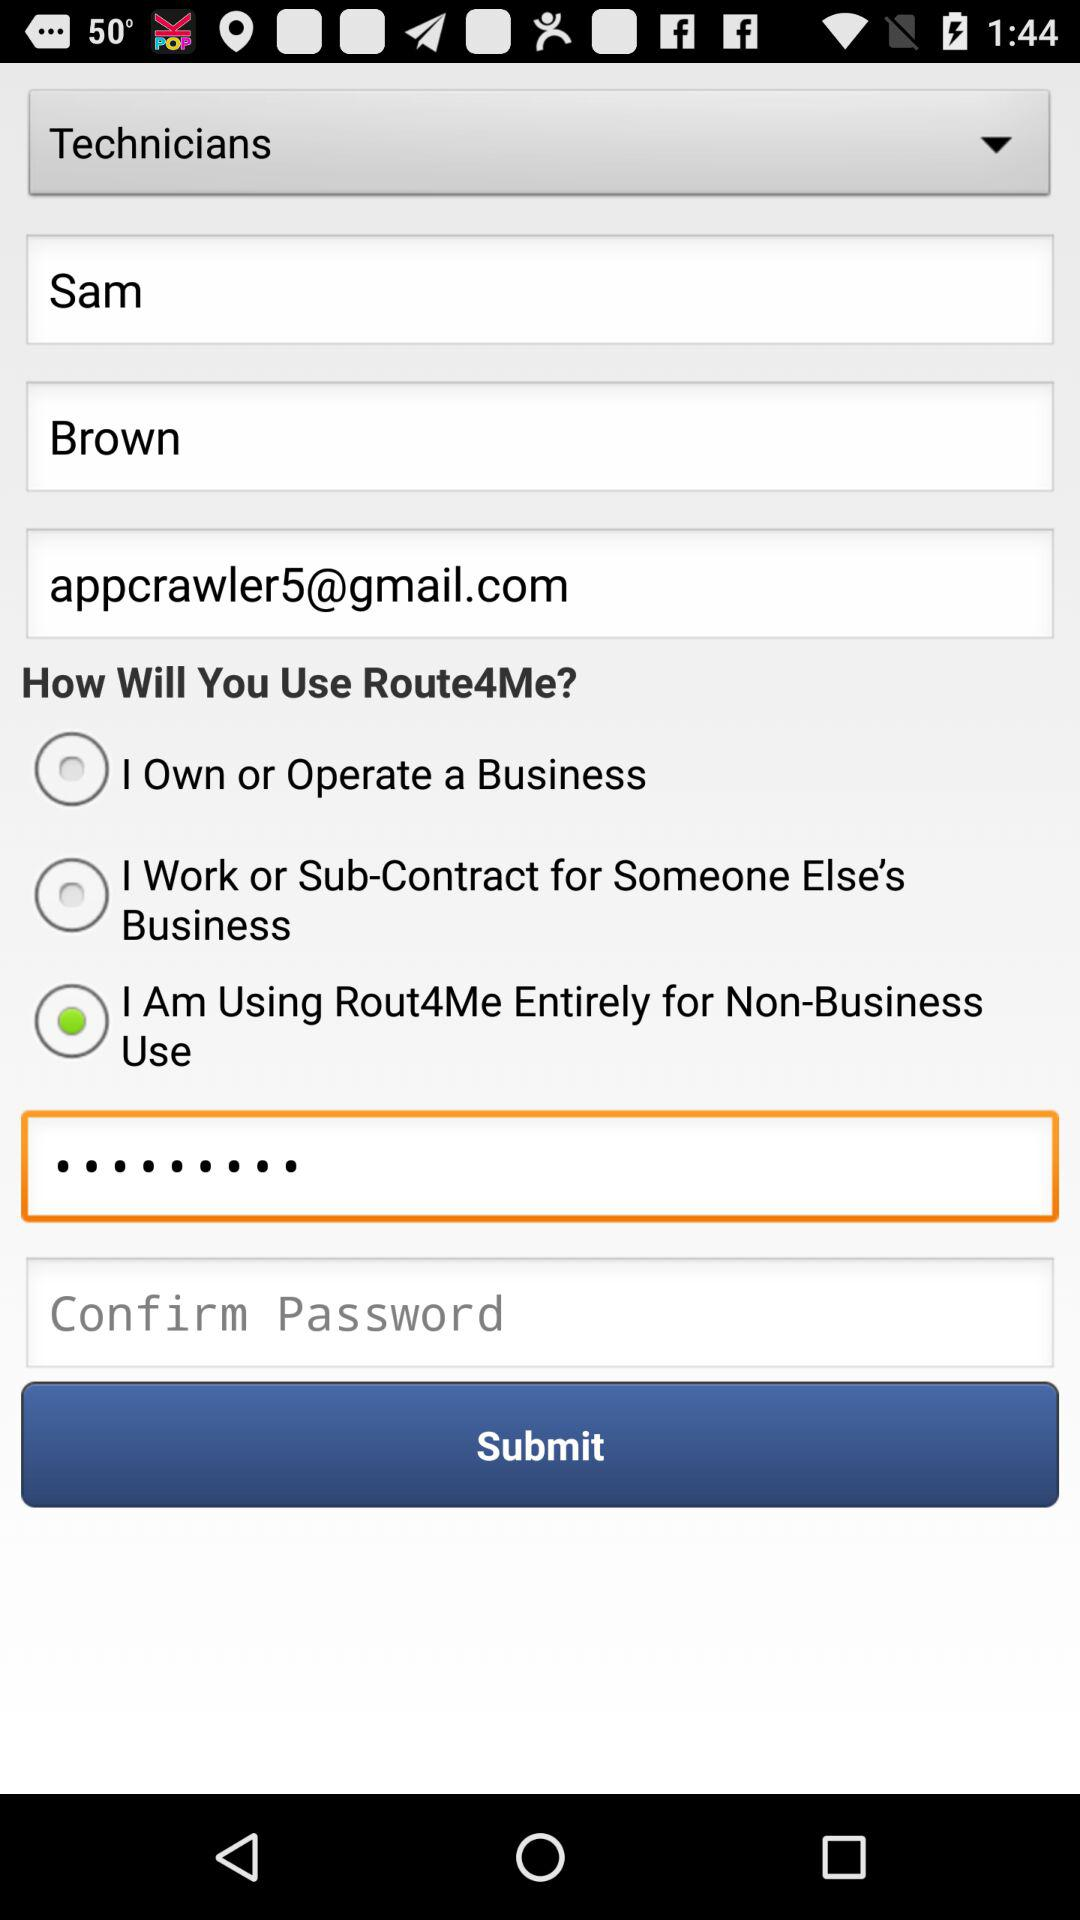What is the last name of the user?
When the provided information is insufficient, respond with <no answer>. <no answer> 